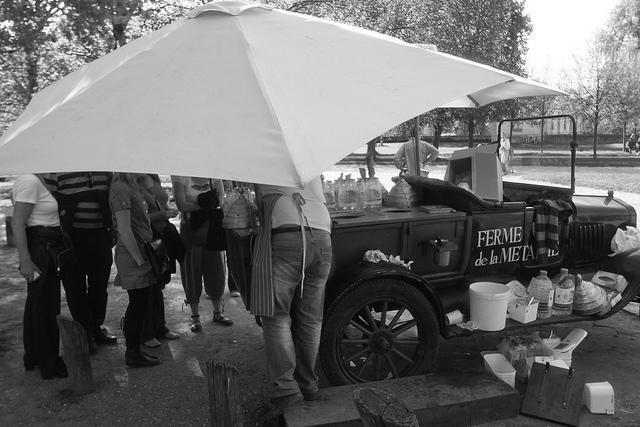How many trucks are there?
Give a very brief answer. 1. How many people are there?
Give a very brief answer. 6. How many birds are there?
Give a very brief answer. 0. 